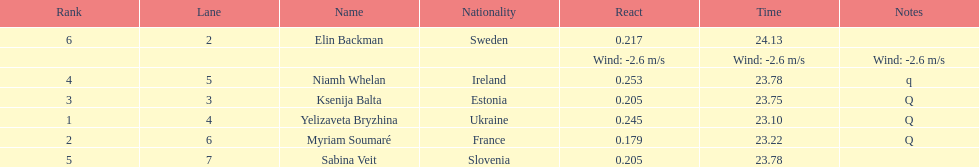Are any of the lanes in consecutive order? No. 